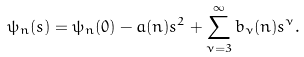Convert formula to latex. <formula><loc_0><loc_0><loc_500><loc_500>\psi _ { n } ( s ) = \psi _ { n } ( 0 ) - a ( n ) s ^ { 2 } + \sum _ { \nu = 3 } ^ { \infty } b _ { \nu } ( n ) s ^ { \nu } .</formula> 